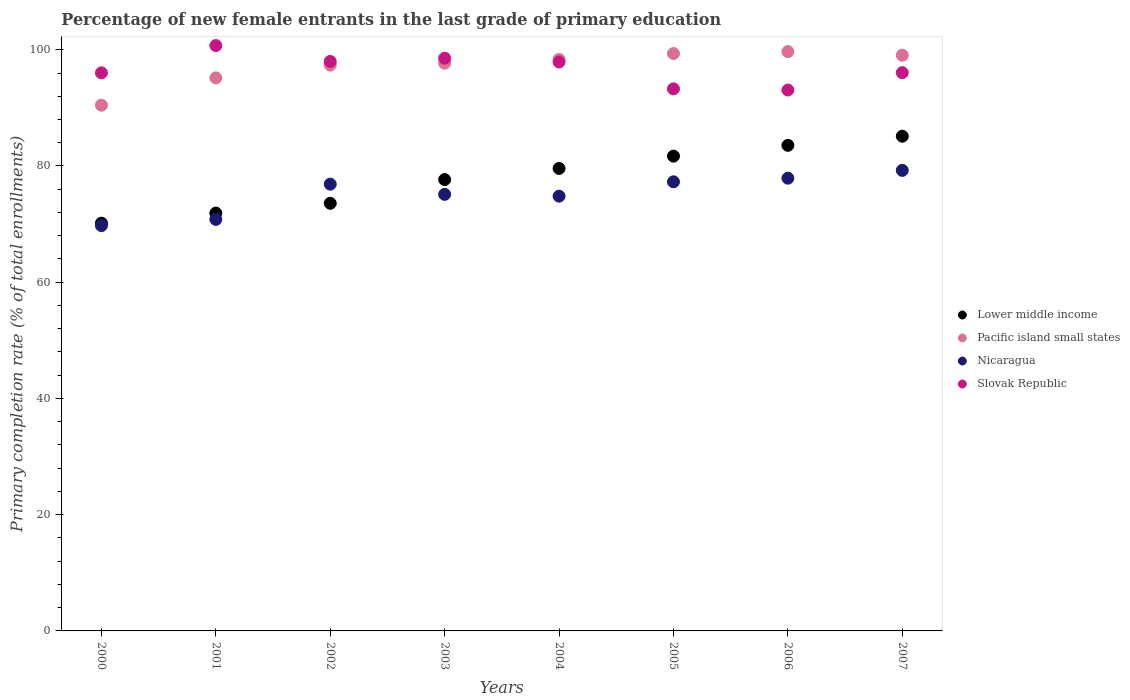What is the percentage of new female entrants in Nicaragua in 2004?
Your answer should be compact. 74.81. Across all years, what is the maximum percentage of new female entrants in Pacific island small states?
Make the answer very short. 99.68. Across all years, what is the minimum percentage of new female entrants in Nicaragua?
Provide a succinct answer. 69.73. In which year was the percentage of new female entrants in Nicaragua minimum?
Make the answer very short. 2000. What is the total percentage of new female entrants in Pacific island small states in the graph?
Your response must be concise. 777.11. What is the difference between the percentage of new female entrants in Lower middle income in 2002 and that in 2006?
Your answer should be very brief. -9.97. What is the difference between the percentage of new female entrants in Lower middle income in 2003 and the percentage of new female entrants in Pacific island small states in 2001?
Keep it short and to the point. -17.49. What is the average percentage of new female entrants in Lower middle income per year?
Your answer should be very brief. 77.91. In the year 2000, what is the difference between the percentage of new female entrants in Pacific island small states and percentage of new female entrants in Slovak Republic?
Offer a terse response. -5.57. In how many years, is the percentage of new female entrants in Lower middle income greater than 96 %?
Your answer should be compact. 0. What is the ratio of the percentage of new female entrants in Slovak Republic in 2002 to that in 2007?
Make the answer very short. 1.02. Is the percentage of new female entrants in Lower middle income in 2001 less than that in 2005?
Make the answer very short. Yes. Is the difference between the percentage of new female entrants in Pacific island small states in 2002 and 2005 greater than the difference between the percentage of new female entrants in Slovak Republic in 2002 and 2005?
Provide a short and direct response. No. What is the difference between the highest and the second highest percentage of new female entrants in Nicaragua?
Make the answer very short. 1.34. What is the difference between the highest and the lowest percentage of new female entrants in Lower middle income?
Your response must be concise. 14.96. Is the sum of the percentage of new female entrants in Lower middle income in 2004 and 2007 greater than the maximum percentage of new female entrants in Slovak Republic across all years?
Give a very brief answer. Yes. Is it the case that in every year, the sum of the percentage of new female entrants in Slovak Republic and percentage of new female entrants in Nicaragua  is greater than the sum of percentage of new female entrants in Lower middle income and percentage of new female entrants in Pacific island small states?
Provide a short and direct response. No. Does the percentage of new female entrants in Slovak Republic monotonically increase over the years?
Your answer should be very brief. No. Is the percentage of new female entrants in Pacific island small states strictly greater than the percentage of new female entrants in Nicaragua over the years?
Your response must be concise. Yes. Is the percentage of new female entrants in Pacific island small states strictly less than the percentage of new female entrants in Nicaragua over the years?
Your answer should be very brief. No. How many dotlines are there?
Your answer should be very brief. 4. How many years are there in the graph?
Give a very brief answer. 8. What is the difference between two consecutive major ticks on the Y-axis?
Provide a short and direct response. 20. Does the graph contain any zero values?
Your answer should be compact. No. How many legend labels are there?
Your response must be concise. 4. How are the legend labels stacked?
Give a very brief answer. Vertical. What is the title of the graph?
Offer a very short reply. Percentage of new female entrants in the last grade of primary education. Does "Jamaica" appear as one of the legend labels in the graph?
Make the answer very short. No. What is the label or title of the X-axis?
Provide a succinct answer. Years. What is the label or title of the Y-axis?
Your answer should be compact. Primary completion rate (% of total enrollments). What is the Primary completion rate (% of total enrollments) of Lower middle income in 2000?
Ensure brevity in your answer.  70.16. What is the Primary completion rate (% of total enrollments) of Pacific island small states in 2000?
Make the answer very short. 90.46. What is the Primary completion rate (% of total enrollments) in Nicaragua in 2000?
Give a very brief answer. 69.73. What is the Primary completion rate (% of total enrollments) in Slovak Republic in 2000?
Keep it short and to the point. 96.03. What is the Primary completion rate (% of total enrollments) of Lower middle income in 2001?
Your answer should be very brief. 71.9. What is the Primary completion rate (% of total enrollments) of Pacific island small states in 2001?
Offer a very short reply. 95.16. What is the Primary completion rate (% of total enrollments) of Nicaragua in 2001?
Ensure brevity in your answer.  70.81. What is the Primary completion rate (% of total enrollments) in Slovak Republic in 2001?
Your response must be concise. 100.72. What is the Primary completion rate (% of total enrollments) of Lower middle income in 2002?
Provide a short and direct response. 73.58. What is the Primary completion rate (% of total enrollments) in Pacific island small states in 2002?
Your answer should be very brief. 97.36. What is the Primary completion rate (% of total enrollments) of Nicaragua in 2002?
Your answer should be very brief. 76.87. What is the Primary completion rate (% of total enrollments) of Slovak Republic in 2002?
Make the answer very short. 98. What is the Primary completion rate (% of total enrollments) in Lower middle income in 2003?
Provide a succinct answer. 77.67. What is the Primary completion rate (% of total enrollments) of Pacific island small states in 2003?
Ensure brevity in your answer.  97.69. What is the Primary completion rate (% of total enrollments) of Nicaragua in 2003?
Your response must be concise. 75.12. What is the Primary completion rate (% of total enrollments) of Slovak Republic in 2003?
Offer a terse response. 98.55. What is the Primary completion rate (% of total enrollments) of Lower middle income in 2004?
Make the answer very short. 79.58. What is the Primary completion rate (% of total enrollments) in Pacific island small states in 2004?
Give a very brief answer. 98.34. What is the Primary completion rate (% of total enrollments) of Nicaragua in 2004?
Ensure brevity in your answer.  74.81. What is the Primary completion rate (% of total enrollments) in Slovak Republic in 2004?
Offer a very short reply. 97.89. What is the Primary completion rate (% of total enrollments) of Lower middle income in 2005?
Provide a short and direct response. 81.69. What is the Primary completion rate (% of total enrollments) of Pacific island small states in 2005?
Provide a succinct answer. 99.35. What is the Primary completion rate (% of total enrollments) of Nicaragua in 2005?
Your answer should be compact. 77.28. What is the Primary completion rate (% of total enrollments) in Slovak Republic in 2005?
Your answer should be very brief. 93.27. What is the Primary completion rate (% of total enrollments) of Lower middle income in 2006?
Your answer should be compact. 83.55. What is the Primary completion rate (% of total enrollments) in Pacific island small states in 2006?
Offer a very short reply. 99.68. What is the Primary completion rate (% of total enrollments) in Nicaragua in 2006?
Make the answer very short. 77.9. What is the Primary completion rate (% of total enrollments) of Slovak Republic in 2006?
Provide a short and direct response. 93.07. What is the Primary completion rate (% of total enrollments) in Lower middle income in 2007?
Offer a terse response. 85.12. What is the Primary completion rate (% of total enrollments) in Pacific island small states in 2007?
Give a very brief answer. 99.06. What is the Primary completion rate (% of total enrollments) in Nicaragua in 2007?
Your response must be concise. 79.25. What is the Primary completion rate (% of total enrollments) of Slovak Republic in 2007?
Offer a terse response. 96.06. Across all years, what is the maximum Primary completion rate (% of total enrollments) of Lower middle income?
Keep it short and to the point. 85.12. Across all years, what is the maximum Primary completion rate (% of total enrollments) of Pacific island small states?
Give a very brief answer. 99.68. Across all years, what is the maximum Primary completion rate (% of total enrollments) of Nicaragua?
Ensure brevity in your answer.  79.25. Across all years, what is the maximum Primary completion rate (% of total enrollments) of Slovak Republic?
Offer a very short reply. 100.72. Across all years, what is the minimum Primary completion rate (% of total enrollments) in Lower middle income?
Give a very brief answer. 70.16. Across all years, what is the minimum Primary completion rate (% of total enrollments) in Pacific island small states?
Keep it short and to the point. 90.46. Across all years, what is the minimum Primary completion rate (% of total enrollments) in Nicaragua?
Offer a very short reply. 69.73. Across all years, what is the minimum Primary completion rate (% of total enrollments) in Slovak Republic?
Keep it short and to the point. 93.07. What is the total Primary completion rate (% of total enrollments) in Lower middle income in the graph?
Your answer should be compact. 623.26. What is the total Primary completion rate (% of total enrollments) of Pacific island small states in the graph?
Keep it short and to the point. 777.11. What is the total Primary completion rate (% of total enrollments) in Nicaragua in the graph?
Keep it short and to the point. 601.77. What is the total Primary completion rate (% of total enrollments) of Slovak Republic in the graph?
Ensure brevity in your answer.  773.6. What is the difference between the Primary completion rate (% of total enrollments) of Lower middle income in 2000 and that in 2001?
Your response must be concise. -1.74. What is the difference between the Primary completion rate (% of total enrollments) of Pacific island small states in 2000 and that in 2001?
Ensure brevity in your answer.  -4.7. What is the difference between the Primary completion rate (% of total enrollments) of Nicaragua in 2000 and that in 2001?
Provide a short and direct response. -1.07. What is the difference between the Primary completion rate (% of total enrollments) in Slovak Republic in 2000 and that in 2001?
Your answer should be very brief. -4.69. What is the difference between the Primary completion rate (% of total enrollments) in Lower middle income in 2000 and that in 2002?
Your answer should be very brief. -3.42. What is the difference between the Primary completion rate (% of total enrollments) of Pacific island small states in 2000 and that in 2002?
Ensure brevity in your answer.  -6.9. What is the difference between the Primary completion rate (% of total enrollments) in Nicaragua in 2000 and that in 2002?
Your answer should be compact. -7.14. What is the difference between the Primary completion rate (% of total enrollments) of Slovak Republic in 2000 and that in 2002?
Your response must be concise. -1.97. What is the difference between the Primary completion rate (% of total enrollments) of Lower middle income in 2000 and that in 2003?
Provide a short and direct response. -7.51. What is the difference between the Primary completion rate (% of total enrollments) in Pacific island small states in 2000 and that in 2003?
Your answer should be very brief. -7.23. What is the difference between the Primary completion rate (% of total enrollments) of Nicaragua in 2000 and that in 2003?
Provide a short and direct response. -5.38. What is the difference between the Primary completion rate (% of total enrollments) in Slovak Republic in 2000 and that in 2003?
Keep it short and to the point. -2.52. What is the difference between the Primary completion rate (% of total enrollments) in Lower middle income in 2000 and that in 2004?
Your answer should be compact. -9.42. What is the difference between the Primary completion rate (% of total enrollments) of Pacific island small states in 2000 and that in 2004?
Offer a very short reply. -7.88. What is the difference between the Primary completion rate (% of total enrollments) of Nicaragua in 2000 and that in 2004?
Make the answer very short. -5.07. What is the difference between the Primary completion rate (% of total enrollments) of Slovak Republic in 2000 and that in 2004?
Ensure brevity in your answer.  -1.86. What is the difference between the Primary completion rate (% of total enrollments) of Lower middle income in 2000 and that in 2005?
Provide a short and direct response. -11.53. What is the difference between the Primary completion rate (% of total enrollments) of Pacific island small states in 2000 and that in 2005?
Provide a short and direct response. -8.89. What is the difference between the Primary completion rate (% of total enrollments) of Nicaragua in 2000 and that in 2005?
Keep it short and to the point. -7.54. What is the difference between the Primary completion rate (% of total enrollments) in Slovak Republic in 2000 and that in 2005?
Ensure brevity in your answer.  2.75. What is the difference between the Primary completion rate (% of total enrollments) of Lower middle income in 2000 and that in 2006?
Provide a short and direct response. -13.39. What is the difference between the Primary completion rate (% of total enrollments) of Pacific island small states in 2000 and that in 2006?
Provide a short and direct response. -9.22. What is the difference between the Primary completion rate (% of total enrollments) of Nicaragua in 2000 and that in 2006?
Give a very brief answer. -8.17. What is the difference between the Primary completion rate (% of total enrollments) of Slovak Republic in 2000 and that in 2006?
Ensure brevity in your answer.  2.96. What is the difference between the Primary completion rate (% of total enrollments) in Lower middle income in 2000 and that in 2007?
Ensure brevity in your answer.  -14.96. What is the difference between the Primary completion rate (% of total enrollments) of Pacific island small states in 2000 and that in 2007?
Provide a short and direct response. -8.6. What is the difference between the Primary completion rate (% of total enrollments) in Nicaragua in 2000 and that in 2007?
Offer a very short reply. -9.51. What is the difference between the Primary completion rate (% of total enrollments) of Slovak Republic in 2000 and that in 2007?
Provide a short and direct response. -0.03. What is the difference between the Primary completion rate (% of total enrollments) in Lower middle income in 2001 and that in 2002?
Give a very brief answer. -1.68. What is the difference between the Primary completion rate (% of total enrollments) of Pacific island small states in 2001 and that in 2002?
Your answer should be very brief. -2.2. What is the difference between the Primary completion rate (% of total enrollments) of Nicaragua in 2001 and that in 2002?
Offer a very short reply. -6.07. What is the difference between the Primary completion rate (% of total enrollments) of Slovak Republic in 2001 and that in 2002?
Your response must be concise. 2.72. What is the difference between the Primary completion rate (% of total enrollments) of Lower middle income in 2001 and that in 2003?
Your response must be concise. -5.77. What is the difference between the Primary completion rate (% of total enrollments) of Pacific island small states in 2001 and that in 2003?
Offer a terse response. -2.53. What is the difference between the Primary completion rate (% of total enrollments) in Nicaragua in 2001 and that in 2003?
Keep it short and to the point. -4.31. What is the difference between the Primary completion rate (% of total enrollments) of Slovak Republic in 2001 and that in 2003?
Provide a short and direct response. 2.17. What is the difference between the Primary completion rate (% of total enrollments) in Lower middle income in 2001 and that in 2004?
Give a very brief answer. -7.68. What is the difference between the Primary completion rate (% of total enrollments) in Pacific island small states in 2001 and that in 2004?
Make the answer very short. -3.18. What is the difference between the Primary completion rate (% of total enrollments) in Nicaragua in 2001 and that in 2004?
Make the answer very short. -4. What is the difference between the Primary completion rate (% of total enrollments) in Slovak Republic in 2001 and that in 2004?
Offer a terse response. 2.83. What is the difference between the Primary completion rate (% of total enrollments) of Lower middle income in 2001 and that in 2005?
Your answer should be compact. -9.79. What is the difference between the Primary completion rate (% of total enrollments) of Pacific island small states in 2001 and that in 2005?
Provide a short and direct response. -4.19. What is the difference between the Primary completion rate (% of total enrollments) in Nicaragua in 2001 and that in 2005?
Ensure brevity in your answer.  -6.47. What is the difference between the Primary completion rate (% of total enrollments) in Slovak Republic in 2001 and that in 2005?
Keep it short and to the point. 7.45. What is the difference between the Primary completion rate (% of total enrollments) in Lower middle income in 2001 and that in 2006?
Keep it short and to the point. -11.65. What is the difference between the Primary completion rate (% of total enrollments) of Pacific island small states in 2001 and that in 2006?
Give a very brief answer. -4.52. What is the difference between the Primary completion rate (% of total enrollments) in Nicaragua in 2001 and that in 2006?
Provide a short and direct response. -7.09. What is the difference between the Primary completion rate (% of total enrollments) in Slovak Republic in 2001 and that in 2006?
Your answer should be compact. 7.65. What is the difference between the Primary completion rate (% of total enrollments) in Lower middle income in 2001 and that in 2007?
Offer a very short reply. -13.22. What is the difference between the Primary completion rate (% of total enrollments) in Pacific island small states in 2001 and that in 2007?
Your answer should be very brief. -3.9. What is the difference between the Primary completion rate (% of total enrollments) of Nicaragua in 2001 and that in 2007?
Provide a short and direct response. -8.44. What is the difference between the Primary completion rate (% of total enrollments) in Slovak Republic in 2001 and that in 2007?
Ensure brevity in your answer.  4.66. What is the difference between the Primary completion rate (% of total enrollments) of Lower middle income in 2002 and that in 2003?
Provide a short and direct response. -4.08. What is the difference between the Primary completion rate (% of total enrollments) of Pacific island small states in 2002 and that in 2003?
Your answer should be very brief. -0.33. What is the difference between the Primary completion rate (% of total enrollments) of Nicaragua in 2002 and that in 2003?
Provide a short and direct response. 1.76. What is the difference between the Primary completion rate (% of total enrollments) in Slovak Republic in 2002 and that in 2003?
Give a very brief answer. -0.55. What is the difference between the Primary completion rate (% of total enrollments) in Lower middle income in 2002 and that in 2004?
Offer a very short reply. -6. What is the difference between the Primary completion rate (% of total enrollments) of Pacific island small states in 2002 and that in 2004?
Keep it short and to the point. -0.98. What is the difference between the Primary completion rate (% of total enrollments) in Nicaragua in 2002 and that in 2004?
Provide a short and direct response. 2.06. What is the difference between the Primary completion rate (% of total enrollments) in Slovak Republic in 2002 and that in 2004?
Your answer should be very brief. 0.1. What is the difference between the Primary completion rate (% of total enrollments) of Lower middle income in 2002 and that in 2005?
Your response must be concise. -8.11. What is the difference between the Primary completion rate (% of total enrollments) in Pacific island small states in 2002 and that in 2005?
Provide a short and direct response. -1.99. What is the difference between the Primary completion rate (% of total enrollments) in Nicaragua in 2002 and that in 2005?
Offer a very short reply. -0.41. What is the difference between the Primary completion rate (% of total enrollments) in Slovak Republic in 2002 and that in 2005?
Provide a short and direct response. 4.72. What is the difference between the Primary completion rate (% of total enrollments) in Lower middle income in 2002 and that in 2006?
Your answer should be very brief. -9.97. What is the difference between the Primary completion rate (% of total enrollments) in Pacific island small states in 2002 and that in 2006?
Keep it short and to the point. -2.33. What is the difference between the Primary completion rate (% of total enrollments) of Nicaragua in 2002 and that in 2006?
Provide a succinct answer. -1.03. What is the difference between the Primary completion rate (% of total enrollments) in Slovak Republic in 2002 and that in 2006?
Provide a short and direct response. 4.92. What is the difference between the Primary completion rate (% of total enrollments) in Lower middle income in 2002 and that in 2007?
Your answer should be very brief. -11.54. What is the difference between the Primary completion rate (% of total enrollments) of Pacific island small states in 2002 and that in 2007?
Ensure brevity in your answer.  -1.71. What is the difference between the Primary completion rate (% of total enrollments) of Nicaragua in 2002 and that in 2007?
Your answer should be compact. -2.37. What is the difference between the Primary completion rate (% of total enrollments) of Slovak Republic in 2002 and that in 2007?
Offer a terse response. 1.94. What is the difference between the Primary completion rate (% of total enrollments) in Lower middle income in 2003 and that in 2004?
Your response must be concise. -1.92. What is the difference between the Primary completion rate (% of total enrollments) of Pacific island small states in 2003 and that in 2004?
Provide a succinct answer. -0.65. What is the difference between the Primary completion rate (% of total enrollments) of Nicaragua in 2003 and that in 2004?
Your answer should be very brief. 0.31. What is the difference between the Primary completion rate (% of total enrollments) of Slovak Republic in 2003 and that in 2004?
Provide a short and direct response. 0.65. What is the difference between the Primary completion rate (% of total enrollments) of Lower middle income in 2003 and that in 2005?
Offer a terse response. -4.03. What is the difference between the Primary completion rate (% of total enrollments) of Pacific island small states in 2003 and that in 2005?
Keep it short and to the point. -1.66. What is the difference between the Primary completion rate (% of total enrollments) of Nicaragua in 2003 and that in 2005?
Your answer should be very brief. -2.16. What is the difference between the Primary completion rate (% of total enrollments) in Slovak Republic in 2003 and that in 2005?
Give a very brief answer. 5.27. What is the difference between the Primary completion rate (% of total enrollments) in Lower middle income in 2003 and that in 2006?
Give a very brief answer. -5.89. What is the difference between the Primary completion rate (% of total enrollments) of Pacific island small states in 2003 and that in 2006?
Provide a short and direct response. -1.99. What is the difference between the Primary completion rate (% of total enrollments) in Nicaragua in 2003 and that in 2006?
Keep it short and to the point. -2.78. What is the difference between the Primary completion rate (% of total enrollments) in Slovak Republic in 2003 and that in 2006?
Keep it short and to the point. 5.48. What is the difference between the Primary completion rate (% of total enrollments) in Lower middle income in 2003 and that in 2007?
Make the answer very short. -7.46. What is the difference between the Primary completion rate (% of total enrollments) in Pacific island small states in 2003 and that in 2007?
Give a very brief answer. -1.37. What is the difference between the Primary completion rate (% of total enrollments) in Nicaragua in 2003 and that in 2007?
Your answer should be compact. -4.13. What is the difference between the Primary completion rate (% of total enrollments) in Slovak Republic in 2003 and that in 2007?
Make the answer very short. 2.49. What is the difference between the Primary completion rate (% of total enrollments) of Lower middle income in 2004 and that in 2005?
Your response must be concise. -2.11. What is the difference between the Primary completion rate (% of total enrollments) in Pacific island small states in 2004 and that in 2005?
Give a very brief answer. -1.01. What is the difference between the Primary completion rate (% of total enrollments) in Nicaragua in 2004 and that in 2005?
Offer a terse response. -2.47. What is the difference between the Primary completion rate (% of total enrollments) of Slovak Republic in 2004 and that in 2005?
Ensure brevity in your answer.  4.62. What is the difference between the Primary completion rate (% of total enrollments) in Lower middle income in 2004 and that in 2006?
Make the answer very short. -3.97. What is the difference between the Primary completion rate (% of total enrollments) of Pacific island small states in 2004 and that in 2006?
Give a very brief answer. -1.34. What is the difference between the Primary completion rate (% of total enrollments) of Nicaragua in 2004 and that in 2006?
Provide a short and direct response. -3.09. What is the difference between the Primary completion rate (% of total enrollments) of Slovak Republic in 2004 and that in 2006?
Make the answer very short. 4.82. What is the difference between the Primary completion rate (% of total enrollments) in Lower middle income in 2004 and that in 2007?
Provide a short and direct response. -5.54. What is the difference between the Primary completion rate (% of total enrollments) in Pacific island small states in 2004 and that in 2007?
Offer a terse response. -0.72. What is the difference between the Primary completion rate (% of total enrollments) in Nicaragua in 2004 and that in 2007?
Offer a terse response. -4.44. What is the difference between the Primary completion rate (% of total enrollments) in Slovak Republic in 2004 and that in 2007?
Your answer should be very brief. 1.84. What is the difference between the Primary completion rate (% of total enrollments) in Lower middle income in 2005 and that in 2006?
Offer a terse response. -1.86. What is the difference between the Primary completion rate (% of total enrollments) of Pacific island small states in 2005 and that in 2006?
Provide a succinct answer. -0.33. What is the difference between the Primary completion rate (% of total enrollments) of Nicaragua in 2005 and that in 2006?
Provide a short and direct response. -0.62. What is the difference between the Primary completion rate (% of total enrollments) in Slovak Republic in 2005 and that in 2006?
Give a very brief answer. 0.2. What is the difference between the Primary completion rate (% of total enrollments) of Lower middle income in 2005 and that in 2007?
Provide a succinct answer. -3.43. What is the difference between the Primary completion rate (% of total enrollments) in Pacific island small states in 2005 and that in 2007?
Provide a short and direct response. 0.29. What is the difference between the Primary completion rate (% of total enrollments) of Nicaragua in 2005 and that in 2007?
Make the answer very short. -1.97. What is the difference between the Primary completion rate (% of total enrollments) in Slovak Republic in 2005 and that in 2007?
Give a very brief answer. -2.78. What is the difference between the Primary completion rate (% of total enrollments) in Lower middle income in 2006 and that in 2007?
Your answer should be compact. -1.57. What is the difference between the Primary completion rate (% of total enrollments) of Pacific island small states in 2006 and that in 2007?
Provide a short and direct response. 0.62. What is the difference between the Primary completion rate (% of total enrollments) in Nicaragua in 2006 and that in 2007?
Make the answer very short. -1.34. What is the difference between the Primary completion rate (% of total enrollments) of Slovak Republic in 2006 and that in 2007?
Provide a short and direct response. -2.99. What is the difference between the Primary completion rate (% of total enrollments) in Lower middle income in 2000 and the Primary completion rate (% of total enrollments) in Pacific island small states in 2001?
Provide a short and direct response. -25. What is the difference between the Primary completion rate (% of total enrollments) of Lower middle income in 2000 and the Primary completion rate (% of total enrollments) of Nicaragua in 2001?
Your response must be concise. -0.65. What is the difference between the Primary completion rate (% of total enrollments) of Lower middle income in 2000 and the Primary completion rate (% of total enrollments) of Slovak Republic in 2001?
Make the answer very short. -30.56. What is the difference between the Primary completion rate (% of total enrollments) of Pacific island small states in 2000 and the Primary completion rate (% of total enrollments) of Nicaragua in 2001?
Offer a very short reply. 19.65. What is the difference between the Primary completion rate (% of total enrollments) in Pacific island small states in 2000 and the Primary completion rate (% of total enrollments) in Slovak Republic in 2001?
Your response must be concise. -10.26. What is the difference between the Primary completion rate (% of total enrollments) of Nicaragua in 2000 and the Primary completion rate (% of total enrollments) of Slovak Republic in 2001?
Ensure brevity in your answer.  -30.99. What is the difference between the Primary completion rate (% of total enrollments) of Lower middle income in 2000 and the Primary completion rate (% of total enrollments) of Pacific island small states in 2002?
Offer a terse response. -27.2. What is the difference between the Primary completion rate (% of total enrollments) in Lower middle income in 2000 and the Primary completion rate (% of total enrollments) in Nicaragua in 2002?
Your response must be concise. -6.71. What is the difference between the Primary completion rate (% of total enrollments) of Lower middle income in 2000 and the Primary completion rate (% of total enrollments) of Slovak Republic in 2002?
Provide a short and direct response. -27.84. What is the difference between the Primary completion rate (% of total enrollments) in Pacific island small states in 2000 and the Primary completion rate (% of total enrollments) in Nicaragua in 2002?
Ensure brevity in your answer.  13.59. What is the difference between the Primary completion rate (% of total enrollments) of Pacific island small states in 2000 and the Primary completion rate (% of total enrollments) of Slovak Republic in 2002?
Provide a short and direct response. -7.54. What is the difference between the Primary completion rate (% of total enrollments) in Nicaragua in 2000 and the Primary completion rate (% of total enrollments) in Slovak Republic in 2002?
Give a very brief answer. -28.26. What is the difference between the Primary completion rate (% of total enrollments) in Lower middle income in 2000 and the Primary completion rate (% of total enrollments) in Pacific island small states in 2003?
Your answer should be compact. -27.53. What is the difference between the Primary completion rate (% of total enrollments) of Lower middle income in 2000 and the Primary completion rate (% of total enrollments) of Nicaragua in 2003?
Your answer should be compact. -4.96. What is the difference between the Primary completion rate (% of total enrollments) in Lower middle income in 2000 and the Primary completion rate (% of total enrollments) in Slovak Republic in 2003?
Your answer should be very brief. -28.39. What is the difference between the Primary completion rate (% of total enrollments) in Pacific island small states in 2000 and the Primary completion rate (% of total enrollments) in Nicaragua in 2003?
Give a very brief answer. 15.34. What is the difference between the Primary completion rate (% of total enrollments) of Pacific island small states in 2000 and the Primary completion rate (% of total enrollments) of Slovak Republic in 2003?
Give a very brief answer. -8.09. What is the difference between the Primary completion rate (% of total enrollments) in Nicaragua in 2000 and the Primary completion rate (% of total enrollments) in Slovak Republic in 2003?
Provide a short and direct response. -28.81. What is the difference between the Primary completion rate (% of total enrollments) of Lower middle income in 2000 and the Primary completion rate (% of total enrollments) of Pacific island small states in 2004?
Provide a succinct answer. -28.18. What is the difference between the Primary completion rate (% of total enrollments) of Lower middle income in 2000 and the Primary completion rate (% of total enrollments) of Nicaragua in 2004?
Your answer should be compact. -4.65. What is the difference between the Primary completion rate (% of total enrollments) of Lower middle income in 2000 and the Primary completion rate (% of total enrollments) of Slovak Republic in 2004?
Your answer should be very brief. -27.73. What is the difference between the Primary completion rate (% of total enrollments) of Pacific island small states in 2000 and the Primary completion rate (% of total enrollments) of Nicaragua in 2004?
Keep it short and to the point. 15.65. What is the difference between the Primary completion rate (% of total enrollments) in Pacific island small states in 2000 and the Primary completion rate (% of total enrollments) in Slovak Republic in 2004?
Your answer should be compact. -7.43. What is the difference between the Primary completion rate (% of total enrollments) in Nicaragua in 2000 and the Primary completion rate (% of total enrollments) in Slovak Republic in 2004?
Ensure brevity in your answer.  -28.16. What is the difference between the Primary completion rate (% of total enrollments) of Lower middle income in 2000 and the Primary completion rate (% of total enrollments) of Pacific island small states in 2005?
Give a very brief answer. -29.19. What is the difference between the Primary completion rate (% of total enrollments) of Lower middle income in 2000 and the Primary completion rate (% of total enrollments) of Nicaragua in 2005?
Your answer should be very brief. -7.12. What is the difference between the Primary completion rate (% of total enrollments) in Lower middle income in 2000 and the Primary completion rate (% of total enrollments) in Slovak Republic in 2005?
Your answer should be compact. -23.11. What is the difference between the Primary completion rate (% of total enrollments) of Pacific island small states in 2000 and the Primary completion rate (% of total enrollments) of Nicaragua in 2005?
Your answer should be compact. 13.18. What is the difference between the Primary completion rate (% of total enrollments) of Pacific island small states in 2000 and the Primary completion rate (% of total enrollments) of Slovak Republic in 2005?
Ensure brevity in your answer.  -2.81. What is the difference between the Primary completion rate (% of total enrollments) in Nicaragua in 2000 and the Primary completion rate (% of total enrollments) in Slovak Republic in 2005?
Your answer should be compact. -23.54. What is the difference between the Primary completion rate (% of total enrollments) in Lower middle income in 2000 and the Primary completion rate (% of total enrollments) in Pacific island small states in 2006?
Your answer should be very brief. -29.52. What is the difference between the Primary completion rate (% of total enrollments) of Lower middle income in 2000 and the Primary completion rate (% of total enrollments) of Nicaragua in 2006?
Provide a succinct answer. -7.74. What is the difference between the Primary completion rate (% of total enrollments) in Lower middle income in 2000 and the Primary completion rate (% of total enrollments) in Slovak Republic in 2006?
Your response must be concise. -22.91. What is the difference between the Primary completion rate (% of total enrollments) in Pacific island small states in 2000 and the Primary completion rate (% of total enrollments) in Nicaragua in 2006?
Give a very brief answer. 12.56. What is the difference between the Primary completion rate (% of total enrollments) in Pacific island small states in 2000 and the Primary completion rate (% of total enrollments) in Slovak Republic in 2006?
Provide a succinct answer. -2.61. What is the difference between the Primary completion rate (% of total enrollments) in Nicaragua in 2000 and the Primary completion rate (% of total enrollments) in Slovak Republic in 2006?
Make the answer very short. -23.34. What is the difference between the Primary completion rate (% of total enrollments) in Lower middle income in 2000 and the Primary completion rate (% of total enrollments) in Pacific island small states in 2007?
Offer a terse response. -28.9. What is the difference between the Primary completion rate (% of total enrollments) of Lower middle income in 2000 and the Primary completion rate (% of total enrollments) of Nicaragua in 2007?
Keep it short and to the point. -9.09. What is the difference between the Primary completion rate (% of total enrollments) of Lower middle income in 2000 and the Primary completion rate (% of total enrollments) of Slovak Republic in 2007?
Provide a short and direct response. -25.9. What is the difference between the Primary completion rate (% of total enrollments) of Pacific island small states in 2000 and the Primary completion rate (% of total enrollments) of Nicaragua in 2007?
Provide a short and direct response. 11.21. What is the difference between the Primary completion rate (% of total enrollments) in Pacific island small states in 2000 and the Primary completion rate (% of total enrollments) in Slovak Republic in 2007?
Ensure brevity in your answer.  -5.6. What is the difference between the Primary completion rate (% of total enrollments) in Nicaragua in 2000 and the Primary completion rate (% of total enrollments) in Slovak Republic in 2007?
Offer a very short reply. -26.32. What is the difference between the Primary completion rate (% of total enrollments) of Lower middle income in 2001 and the Primary completion rate (% of total enrollments) of Pacific island small states in 2002?
Give a very brief answer. -25.46. What is the difference between the Primary completion rate (% of total enrollments) of Lower middle income in 2001 and the Primary completion rate (% of total enrollments) of Nicaragua in 2002?
Offer a terse response. -4.97. What is the difference between the Primary completion rate (% of total enrollments) of Lower middle income in 2001 and the Primary completion rate (% of total enrollments) of Slovak Republic in 2002?
Make the answer very short. -26.1. What is the difference between the Primary completion rate (% of total enrollments) of Pacific island small states in 2001 and the Primary completion rate (% of total enrollments) of Nicaragua in 2002?
Give a very brief answer. 18.29. What is the difference between the Primary completion rate (% of total enrollments) in Pacific island small states in 2001 and the Primary completion rate (% of total enrollments) in Slovak Republic in 2002?
Offer a terse response. -2.84. What is the difference between the Primary completion rate (% of total enrollments) in Nicaragua in 2001 and the Primary completion rate (% of total enrollments) in Slovak Republic in 2002?
Your answer should be compact. -27.19. What is the difference between the Primary completion rate (% of total enrollments) of Lower middle income in 2001 and the Primary completion rate (% of total enrollments) of Pacific island small states in 2003?
Your answer should be compact. -25.79. What is the difference between the Primary completion rate (% of total enrollments) of Lower middle income in 2001 and the Primary completion rate (% of total enrollments) of Nicaragua in 2003?
Offer a terse response. -3.22. What is the difference between the Primary completion rate (% of total enrollments) in Lower middle income in 2001 and the Primary completion rate (% of total enrollments) in Slovak Republic in 2003?
Your answer should be compact. -26.65. What is the difference between the Primary completion rate (% of total enrollments) of Pacific island small states in 2001 and the Primary completion rate (% of total enrollments) of Nicaragua in 2003?
Your response must be concise. 20.04. What is the difference between the Primary completion rate (% of total enrollments) of Pacific island small states in 2001 and the Primary completion rate (% of total enrollments) of Slovak Republic in 2003?
Your answer should be very brief. -3.39. What is the difference between the Primary completion rate (% of total enrollments) in Nicaragua in 2001 and the Primary completion rate (% of total enrollments) in Slovak Republic in 2003?
Give a very brief answer. -27.74. What is the difference between the Primary completion rate (% of total enrollments) in Lower middle income in 2001 and the Primary completion rate (% of total enrollments) in Pacific island small states in 2004?
Provide a short and direct response. -26.44. What is the difference between the Primary completion rate (% of total enrollments) of Lower middle income in 2001 and the Primary completion rate (% of total enrollments) of Nicaragua in 2004?
Give a very brief answer. -2.91. What is the difference between the Primary completion rate (% of total enrollments) in Lower middle income in 2001 and the Primary completion rate (% of total enrollments) in Slovak Republic in 2004?
Your answer should be compact. -25.99. What is the difference between the Primary completion rate (% of total enrollments) in Pacific island small states in 2001 and the Primary completion rate (% of total enrollments) in Nicaragua in 2004?
Provide a succinct answer. 20.35. What is the difference between the Primary completion rate (% of total enrollments) in Pacific island small states in 2001 and the Primary completion rate (% of total enrollments) in Slovak Republic in 2004?
Your answer should be compact. -2.73. What is the difference between the Primary completion rate (% of total enrollments) in Nicaragua in 2001 and the Primary completion rate (% of total enrollments) in Slovak Republic in 2004?
Offer a terse response. -27.09. What is the difference between the Primary completion rate (% of total enrollments) in Lower middle income in 2001 and the Primary completion rate (% of total enrollments) in Pacific island small states in 2005?
Give a very brief answer. -27.45. What is the difference between the Primary completion rate (% of total enrollments) in Lower middle income in 2001 and the Primary completion rate (% of total enrollments) in Nicaragua in 2005?
Your answer should be compact. -5.38. What is the difference between the Primary completion rate (% of total enrollments) of Lower middle income in 2001 and the Primary completion rate (% of total enrollments) of Slovak Republic in 2005?
Give a very brief answer. -21.38. What is the difference between the Primary completion rate (% of total enrollments) of Pacific island small states in 2001 and the Primary completion rate (% of total enrollments) of Nicaragua in 2005?
Ensure brevity in your answer.  17.88. What is the difference between the Primary completion rate (% of total enrollments) in Pacific island small states in 2001 and the Primary completion rate (% of total enrollments) in Slovak Republic in 2005?
Ensure brevity in your answer.  1.89. What is the difference between the Primary completion rate (% of total enrollments) in Nicaragua in 2001 and the Primary completion rate (% of total enrollments) in Slovak Republic in 2005?
Offer a very short reply. -22.47. What is the difference between the Primary completion rate (% of total enrollments) in Lower middle income in 2001 and the Primary completion rate (% of total enrollments) in Pacific island small states in 2006?
Your answer should be very brief. -27.78. What is the difference between the Primary completion rate (% of total enrollments) of Lower middle income in 2001 and the Primary completion rate (% of total enrollments) of Nicaragua in 2006?
Make the answer very short. -6. What is the difference between the Primary completion rate (% of total enrollments) of Lower middle income in 2001 and the Primary completion rate (% of total enrollments) of Slovak Republic in 2006?
Provide a succinct answer. -21.17. What is the difference between the Primary completion rate (% of total enrollments) of Pacific island small states in 2001 and the Primary completion rate (% of total enrollments) of Nicaragua in 2006?
Your response must be concise. 17.26. What is the difference between the Primary completion rate (% of total enrollments) in Pacific island small states in 2001 and the Primary completion rate (% of total enrollments) in Slovak Republic in 2006?
Your answer should be very brief. 2.09. What is the difference between the Primary completion rate (% of total enrollments) of Nicaragua in 2001 and the Primary completion rate (% of total enrollments) of Slovak Republic in 2006?
Offer a very short reply. -22.26. What is the difference between the Primary completion rate (% of total enrollments) in Lower middle income in 2001 and the Primary completion rate (% of total enrollments) in Pacific island small states in 2007?
Provide a succinct answer. -27.16. What is the difference between the Primary completion rate (% of total enrollments) in Lower middle income in 2001 and the Primary completion rate (% of total enrollments) in Nicaragua in 2007?
Give a very brief answer. -7.35. What is the difference between the Primary completion rate (% of total enrollments) of Lower middle income in 2001 and the Primary completion rate (% of total enrollments) of Slovak Republic in 2007?
Give a very brief answer. -24.16. What is the difference between the Primary completion rate (% of total enrollments) in Pacific island small states in 2001 and the Primary completion rate (% of total enrollments) in Nicaragua in 2007?
Your answer should be very brief. 15.91. What is the difference between the Primary completion rate (% of total enrollments) in Pacific island small states in 2001 and the Primary completion rate (% of total enrollments) in Slovak Republic in 2007?
Provide a short and direct response. -0.9. What is the difference between the Primary completion rate (% of total enrollments) of Nicaragua in 2001 and the Primary completion rate (% of total enrollments) of Slovak Republic in 2007?
Ensure brevity in your answer.  -25.25. What is the difference between the Primary completion rate (% of total enrollments) in Lower middle income in 2002 and the Primary completion rate (% of total enrollments) in Pacific island small states in 2003?
Offer a very short reply. -24.11. What is the difference between the Primary completion rate (% of total enrollments) in Lower middle income in 2002 and the Primary completion rate (% of total enrollments) in Nicaragua in 2003?
Your response must be concise. -1.54. What is the difference between the Primary completion rate (% of total enrollments) in Lower middle income in 2002 and the Primary completion rate (% of total enrollments) in Slovak Republic in 2003?
Keep it short and to the point. -24.97. What is the difference between the Primary completion rate (% of total enrollments) of Pacific island small states in 2002 and the Primary completion rate (% of total enrollments) of Nicaragua in 2003?
Give a very brief answer. 22.24. What is the difference between the Primary completion rate (% of total enrollments) in Pacific island small states in 2002 and the Primary completion rate (% of total enrollments) in Slovak Republic in 2003?
Ensure brevity in your answer.  -1.19. What is the difference between the Primary completion rate (% of total enrollments) of Nicaragua in 2002 and the Primary completion rate (% of total enrollments) of Slovak Republic in 2003?
Keep it short and to the point. -21.68. What is the difference between the Primary completion rate (% of total enrollments) in Lower middle income in 2002 and the Primary completion rate (% of total enrollments) in Pacific island small states in 2004?
Provide a succinct answer. -24.76. What is the difference between the Primary completion rate (% of total enrollments) in Lower middle income in 2002 and the Primary completion rate (% of total enrollments) in Nicaragua in 2004?
Provide a succinct answer. -1.23. What is the difference between the Primary completion rate (% of total enrollments) in Lower middle income in 2002 and the Primary completion rate (% of total enrollments) in Slovak Republic in 2004?
Keep it short and to the point. -24.31. What is the difference between the Primary completion rate (% of total enrollments) of Pacific island small states in 2002 and the Primary completion rate (% of total enrollments) of Nicaragua in 2004?
Offer a very short reply. 22.55. What is the difference between the Primary completion rate (% of total enrollments) in Pacific island small states in 2002 and the Primary completion rate (% of total enrollments) in Slovak Republic in 2004?
Make the answer very short. -0.54. What is the difference between the Primary completion rate (% of total enrollments) of Nicaragua in 2002 and the Primary completion rate (% of total enrollments) of Slovak Republic in 2004?
Offer a terse response. -21.02. What is the difference between the Primary completion rate (% of total enrollments) in Lower middle income in 2002 and the Primary completion rate (% of total enrollments) in Pacific island small states in 2005?
Provide a succinct answer. -25.77. What is the difference between the Primary completion rate (% of total enrollments) of Lower middle income in 2002 and the Primary completion rate (% of total enrollments) of Nicaragua in 2005?
Offer a terse response. -3.7. What is the difference between the Primary completion rate (% of total enrollments) in Lower middle income in 2002 and the Primary completion rate (% of total enrollments) in Slovak Republic in 2005?
Provide a succinct answer. -19.69. What is the difference between the Primary completion rate (% of total enrollments) in Pacific island small states in 2002 and the Primary completion rate (% of total enrollments) in Nicaragua in 2005?
Offer a very short reply. 20.08. What is the difference between the Primary completion rate (% of total enrollments) of Pacific island small states in 2002 and the Primary completion rate (% of total enrollments) of Slovak Republic in 2005?
Keep it short and to the point. 4.08. What is the difference between the Primary completion rate (% of total enrollments) in Nicaragua in 2002 and the Primary completion rate (% of total enrollments) in Slovak Republic in 2005?
Offer a terse response. -16.4. What is the difference between the Primary completion rate (% of total enrollments) in Lower middle income in 2002 and the Primary completion rate (% of total enrollments) in Pacific island small states in 2006?
Provide a short and direct response. -26.1. What is the difference between the Primary completion rate (% of total enrollments) of Lower middle income in 2002 and the Primary completion rate (% of total enrollments) of Nicaragua in 2006?
Keep it short and to the point. -4.32. What is the difference between the Primary completion rate (% of total enrollments) in Lower middle income in 2002 and the Primary completion rate (% of total enrollments) in Slovak Republic in 2006?
Keep it short and to the point. -19.49. What is the difference between the Primary completion rate (% of total enrollments) of Pacific island small states in 2002 and the Primary completion rate (% of total enrollments) of Nicaragua in 2006?
Your answer should be very brief. 19.46. What is the difference between the Primary completion rate (% of total enrollments) of Pacific island small states in 2002 and the Primary completion rate (% of total enrollments) of Slovak Republic in 2006?
Keep it short and to the point. 4.28. What is the difference between the Primary completion rate (% of total enrollments) in Nicaragua in 2002 and the Primary completion rate (% of total enrollments) in Slovak Republic in 2006?
Offer a terse response. -16.2. What is the difference between the Primary completion rate (% of total enrollments) in Lower middle income in 2002 and the Primary completion rate (% of total enrollments) in Pacific island small states in 2007?
Ensure brevity in your answer.  -25.48. What is the difference between the Primary completion rate (% of total enrollments) of Lower middle income in 2002 and the Primary completion rate (% of total enrollments) of Nicaragua in 2007?
Your answer should be compact. -5.66. What is the difference between the Primary completion rate (% of total enrollments) in Lower middle income in 2002 and the Primary completion rate (% of total enrollments) in Slovak Republic in 2007?
Provide a succinct answer. -22.48. What is the difference between the Primary completion rate (% of total enrollments) of Pacific island small states in 2002 and the Primary completion rate (% of total enrollments) of Nicaragua in 2007?
Offer a very short reply. 18.11. What is the difference between the Primary completion rate (% of total enrollments) of Pacific island small states in 2002 and the Primary completion rate (% of total enrollments) of Slovak Republic in 2007?
Provide a succinct answer. 1.3. What is the difference between the Primary completion rate (% of total enrollments) of Nicaragua in 2002 and the Primary completion rate (% of total enrollments) of Slovak Republic in 2007?
Your answer should be very brief. -19.19. What is the difference between the Primary completion rate (% of total enrollments) of Lower middle income in 2003 and the Primary completion rate (% of total enrollments) of Pacific island small states in 2004?
Your answer should be very brief. -20.67. What is the difference between the Primary completion rate (% of total enrollments) of Lower middle income in 2003 and the Primary completion rate (% of total enrollments) of Nicaragua in 2004?
Make the answer very short. 2.86. What is the difference between the Primary completion rate (% of total enrollments) of Lower middle income in 2003 and the Primary completion rate (% of total enrollments) of Slovak Republic in 2004?
Keep it short and to the point. -20.23. What is the difference between the Primary completion rate (% of total enrollments) in Pacific island small states in 2003 and the Primary completion rate (% of total enrollments) in Nicaragua in 2004?
Your answer should be very brief. 22.88. What is the difference between the Primary completion rate (% of total enrollments) in Pacific island small states in 2003 and the Primary completion rate (% of total enrollments) in Slovak Republic in 2004?
Keep it short and to the point. -0.2. What is the difference between the Primary completion rate (% of total enrollments) of Nicaragua in 2003 and the Primary completion rate (% of total enrollments) of Slovak Republic in 2004?
Make the answer very short. -22.78. What is the difference between the Primary completion rate (% of total enrollments) of Lower middle income in 2003 and the Primary completion rate (% of total enrollments) of Pacific island small states in 2005?
Give a very brief answer. -21.69. What is the difference between the Primary completion rate (% of total enrollments) in Lower middle income in 2003 and the Primary completion rate (% of total enrollments) in Nicaragua in 2005?
Ensure brevity in your answer.  0.39. What is the difference between the Primary completion rate (% of total enrollments) of Lower middle income in 2003 and the Primary completion rate (% of total enrollments) of Slovak Republic in 2005?
Ensure brevity in your answer.  -15.61. What is the difference between the Primary completion rate (% of total enrollments) in Pacific island small states in 2003 and the Primary completion rate (% of total enrollments) in Nicaragua in 2005?
Your response must be concise. 20.41. What is the difference between the Primary completion rate (% of total enrollments) of Pacific island small states in 2003 and the Primary completion rate (% of total enrollments) of Slovak Republic in 2005?
Your answer should be compact. 4.42. What is the difference between the Primary completion rate (% of total enrollments) in Nicaragua in 2003 and the Primary completion rate (% of total enrollments) in Slovak Republic in 2005?
Keep it short and to the point. -18.16. What is the difference between the Primary completion rate (% of total enrollments) in Lower middle income in 2003 and the Primary completion rate (% of total enrollments) in Pacific island small states in 2006?
Provide a short and direct response. -22.02. What is the difference between the Primary completion rate (% of total enrollments) of Lower middle income in 2003 and the Primary completion rate (% of total enrollments) of Nicaragua in 2006?
Your response must be concise. -0.24. What is the difference between the Primary completion rate (% of total enrollments) of Lower middle income in 2003 and the Primary completion rate (% of total enrollments) of Slovak Republic in 2006?
Give a very brief answer. -15.41. What is the difference between the Primary completion rate (% of total enrollments) in Pacific island small states in 2003 and the Primary completion rate (% of total enrollments) in Nicaragua in 2006?
Ensure brevity in your answer.  19.79. What is the difference between the Primary completion rate (% of total enrollments) of Pacific island small states in 2003 and the Primary completion rate (% of total enrollments) of Slovak Republic in 2006?
Offer a very short reply. 4.62. What is the difference between the Primary completion rate (% of total enrollments) in Nicaragua in 2003 and the Primary completion rate (% of total enrollments) in Slovak Republic in 2006?
Your answer should be very brief. -17.95. What is the difference between the Primary completion rate (% of total enrollments) in Lower middle income in 2003 and the Primary completion rate (% of total enrollments) in Pacific island small states in 2007?
Your answer should be compact. -21.4. What is the difference between the Primary completion rate (% of total enrollments) in Lower middle income in 2003 and the Primary completion rate (% of total enrollments) in Nicaragua in 2007?
Your answer should be compact. -1.58. What is the difference between the Primary completion rate (% of total enrollments) of Lower middle income in 2003 and the Primary completion rate (% of total enrollments) of Slovak Republic in 2007?
Provide a short and direct response. -18.39. What is the difference between the Primary completion rate (% of total enrollments) of Pacific island small states in 2003 and the Primary completion rate (% of total enrollments) of Nicaragua in 2007?
Offer a terse response. 18.44. What is the difference between the Primary completion rate (% of total enrollments) of Pacific island small states in 2003 and the Primary completion rate (% of total enrollments) of Slovak Republic in 2007?
Ensure brevity in your answer.  1.63. What is the difference between the Primary completion rate (% of total enrollments) of Nicaragua in 2003 and the Primary completion rate (% of total enrollments) of Slovak Republic in 2007?
Your answer should be very brief. -20.94. What is the difference between the Primary completion rate (% of total enrollments) of Lower middle income in 2004 and the Primary completion rate (% of total enrollments) of Pacific island small states in 2005?
Your answer should be very brief. -19.77. What is the difference between the Primary completion rate (% of total enrollments) of Lower middle income in 2004 and the Primary completion rate (% of total enrollments) of Nicaragua in 2005?
Your answer should be compact. 2.3. What is the difference between the Primary completion rate (% of total enrollments) of Lower middle income in 2004 and the Primary completion rate (% of total enrollments) of Slovak Republic in 2005?
Provide a succinct answer. -13.69. What is the difference between the Primary completion rate (% of total enrollments) in Pacific island small states in 2004 and the Primary completion rate (% of total enrollments) in Nicaragua in 2005?
Ensure brevity in your answer.  21.06. What is the difference between the Primary completion rate (% of total enrollments) of Pacific island small states in 2004 and the Primary completion rate (% of total enrollments) of Slovak Republic in 2005?
Keep it short and to the point. 5.07. What is the difference between the Primary completion rate (% of total enrollments) in Nicaragua in 2004 and the Primary completion rate (% of total enrollments) in Slovak Republic in 2005?
Your answer should be very brief. -18.47. What is the difference between the Primary completion rate (% of total enrollments) in Lower middle income in 2004 and the Primary completion rate (% of total enrollments) in Pacific island small states in 2006?
Provide a succinct answer. -20.1. What is the difference between the Primary completion rate (% of total enrollments) of Lower middle income in 2004 and the Primary completion rate (% of total enrollments) of Nicaragua in 2006?
Provide a short and direct response. 1.68. What is the difference between the Primary completion rate (% of total enrollments) in Lower middle income in 2004 and the Primary completion rate (% of total enrollments) in Slovak Republic in 2006?
Your answer should be compact. -13.49. What is the difference between the Primary completion rate (% of total enrollments) of Pacific island small states in 2004 and the Primary completion rate (% of total enrollments) of Nicaragua in 2006?
Provide a succinct answer. 20.44. What is the difference between the Primary completion rate (% of total enrollments) in Pacific island small states in 2004 and the Primary completion rate (% of total enrollments) in Slovak Republic in 2006?
Offer a very short reply. 5.27. What is the difference between the Primary completion rate (% of total enrollments) in Nicaragua in 2004 and the Primary completion rate (% of total enrollments) in Slovak Republic in 2006?
Keep it short and to the point. -18.26. What is the difference between the Primary completion rate (% of total enrollments) of Lower middle income in 2004 and the Primary completion rate (% of total enrollments) of Pacific island small states in 2007?
Your answer should be compact. -19.48. What is the difference between the Primary completion rate (% of total enrollments) in Lower middle income in 2004 and the Primary completion rate (% of total enrollments) in Nicaragua in 2007?
Give a very brief answer. 0.33. What is the difference between the Primary completion rate (% of total enrollments) in Lower middle income in 2004 and the Primary completion rate (% of total enrollments) in Slovak Republic in 2007?
Your response must be concise. -16.48. What is the difference between the Primary completion rate (% of total enrollments) in Pacific island small states in 2004 and the Primary completion rate (% of total enrollments) in Nicaragua in 2007?
Your answer should be very brief. 19.09. What is the difference between the Primary completion rate (% of total enrollments) in Pacific island small states in 2004 and the Primary completion rate (% of total enrollments) in Slovak Republic in 2007?
Provide a short and direct response. 2.28. What is the difference between the Primary completion rate (% of total enrollments) in Nicaragua in 2004 and the Primary completion rate (% of total enrollments) in Slovak Republic in 2007?
Make the answer very short. -21.25. What is the difference between the Primary completion rate (% of total enrollments) in Lower middle income in 2005 and the Primary completion rate (% of total enrollments) in Pacific island small states in 2006?
Give a very brief answer. -17.99. What is the difference between the Primary completion rate (% of total enrollments) of Lower middle income in 2005 and the Primary completion rate (% of total enrollments) of Nicaragua in 2006?
Give a very brief answer. 3.79. What is the difference between the Primary completion rate (% of total enrollments) of Lower middle income in 2005 and the Primary completion rate (% of total enrollments) of Slovak Republic in 2006?
Provide a short and direct response. -11.38. What is the difference between the Primary completion rate (% of total enrollments) in Pacific island small states in 2005 and the Primary completion rate (% of total enrollments) in Nicaragua in 2006?
Your answer should be very brief. 21.45. What is the difference between the Primary completion rate (% of total enrollments) of Pacific island small states in 2005 and the Primary completion rate (% of total enrollments) of Slovak Republic in 2006?
Provide a short and direct response. 6.28. What is the difference between the Primary completion rate (% of total enrollments) of Nicaragua in 2005 and the Primary completion rate (% of total enrollments) of Slovak Republic in 2006?
Give a very brief answer. -15.79. What is the difference between the Primary completion rate (% of total enrollments) in Lower middle income in 2005 and the Primary completion rate (% of total enrollments) in Pacific island small states in 2007?
Your response must be concise. -17.37. What is the difference between the Primary completion rate (% of total enrollments) of Lower middle income in 2005 and the Primary completion rate (% of total enrollments) of Nicaragua in 2007?
Your answer should be compact. 2.45. What is the difference between the Primary completion rate (% of total enrollments) in Lower middle income in 2005 and the Primary completion rate (% of total enrollments) in Slovak Republic in 2007?
Make the answer very short. -14.37. What is the difference between the Primary completion rate (% of total enrollments) in Pacific island small states in 2005 and the Primary completion rate (% of total enrollments) in Nicaragua in 2007?
Offer a very short reply. 20.11. What is the difference between the Primary completion rate (% of total enrollments) in Pacific island small states in 2005 and the Primary completion rate (% of total enrollments) in Slovak Republic in 2007?
Provide a short and direct response. 3.29. What is the difference between the Primary completion rate (% of total enrollments) in Nicaragua in 2005 and the Primary completion rate (% of total enrollments) in Slovak Republic in 2007?
Your answer should be compact. -18.78. What is the difference between the Primary completion rate (% of total enrollments) in Lower middle income in 2006 and the Primary completion rate (% of total enrollments) in Pacific island small states in 2007?
Your answer should be compact. -15.51. What is the difference between the Primary completion rate (% of total enrollments) of Lower middle income in 2006 and the Primary completion rate (% of total enrollments) of Nicaragua in 2007?
Offer a very short reply. 4.31. What is the difference between the Primary completion rate (% of total enrollments) in Lower middle income in 2006 and the Primary completion rate (% of total enrollments) in Slovak Republic in 2007?
Your answer should be very brief. -12.5. What is the difference between the Primary completion rate (% of total enrollments) in Pacific island small states in 2006 and the Primary completion rate (% of total enrollments) in Nicaragua in 2007?
Your answer should be very brief. 20.44. What is the difference between the Primary completion rate (% of total enrollments) of Pacific island small states in 2006 and the Primary completion rate (% of total enrollments) of Slovak Republic in 2007?
Give a very brief answer. 3.62. What is the difference between the Primary completion rate (% of total enrollments) in Nicaragua in 2006 and the Primary completion rate (% of total enrollments) in Slovak Republic in 2007?
Give a very brief answer. -18.16. What is the average Primary completion rate (% of total enrollments) of Lower middle income per year?
Make the answer very short. 77.91. What is the average Primary completion rate (% of total enrollments) in Pacific island small states per year?
Give a very brief answer. 97.14. What is the average Primary completion rate (% of total enrollments) in Nicaragua per year?
Offer a very short reply. 75.22. What is the average Primary completion rate (% of total enrollments) in Slovak Republic per year?
Offer a terse response. 96.7. In the year 2000, what is the difference between the Primary completion rate (% of total enrollments) in Lower middle income and Primary completion rate (% of total enrollments) in Pacific island small states?
Make the answer very short. -20.3. In the year 2000, what is the difference between the Primary completion rate (% of total enrollments) in Lower middle income and Primary completion rate (% of total enrollments) in Nicaragua?
Offer a terse response. 0.43. In the year 2000, what is the difference between the Primary completion rate (% of total enrollments) in Lower middle income and Primary completion rate (% of total enrollments) in Slovak Republic?
Provide a succinct answer. -25.87. In the year 2000, what is the difference between the Primary completion rate (% of total enrollments) in Pacific island small states and Primary completion rate (% of total enrollments) in Nicaragua?
Your answer should be very brief. 20.73. In the year 2000, what is the difference between the Primary completion rate (% of total enrollments) in Pacific island small states and Primary completion rate (% of total enrollments) in Slovak Republic?
Make the answer very short. -5.57. In the year 2000, what is the difference between the Primary completion rate (% of total enrollments) of Nicaragua and Primary completion rate (% of total enrollments) of Slovak Republic?
Provide a succinct answer. -26.3. In the year 2001, what is the difference between the Primary completion rate (% of total enrollments) of Lower middle income and Primary completion rate (% of total enrollments) of Pacific island small states?
Ensure brevity in your answer.  -23.26. In the year 2001, what is the difference between the Primary completion rate (% of total enrollments) in Lower middle income and Primary completion rate (% of total enrollments) in Nicaragua?
Your answer should be compact. 1.09. In the year 2001, what is the difference between the Primary completion rate (% of total enrollments) of Lower middle income and Primary completion rate (% of total enrollments) of Slovak Republic?
Give a very brief answer. -28.82. In the year 2001, what is the difference between the Primary completion rate (% of total enrollments) of Pacific island small states and Primary completion rate (% of total enrollments) of Nicaragua?
Offer a terse response. 24.35. In the year 2001, what is the difference between the Primary completion rate (% of total enrollments) of Pacific island small states and Primary completion rate (% of total enrollments) of Slovak Republic?
Make the answer very short. -5.56. In the year 2001, what is the difference between the Primary completion rate (% of total enrollments) of Nicaragua and Primary completion rate (% of total enrollments) of Slovak Republic?
Your response must be concise. -29.91. In the year 2002, what is the difference between the Primary completion rate (% of total enrollments) of Lower middle income and Primary completion rate (% of total enrollments) of Pacific island small states?
Your answer should be compact. -23.78. In the year 2002, what is the difference between the Primary completion rate (% of total enrollments) in Lower middle income and Primary completion rate (% of total enrollments) in Nicaragua?
Your answer should be very brief. -3.29. In the year 2002, what is the difference between the Primary completion rate (% of total enrollments) in Lower middle income and Primary completion rate (% of total enrollments) in Slovak Republic?
Give a very brief answer. -24.42. In the year 2002, what is the difference between the Primary completion rate (% of total enrollments) of Pacific island small states and Primary completion rate (% of total enrollments) of Nicaragua?
Give a very brief answer. 20.48. In the year 2002, what is the difference between the Primary completion rate (% of total enrollments) of Pacific island small states and Primary completion rate (% of total enrollments) of Slovak Republic?
Keep it short and to the point. -0.64. In the year 2002, what is the difference between the Primary completion rate (% of total enrollments) of Nicaragua and Primary completion rate (% of total enrollments) of Slovak Republic?
Your response must be concise. -21.12. In the year 2003, what is the difference between the Primary completion rate (% of total enrollments) of Lower middle income and Primary completion rate (% of total enrollments) of Pacific island small states?
Give a very brief answer. -20.03. In the year 2003, what is the difference between the Primary completion rate (% of total enrollments) of Lower middle income and Primary completion rate (% of total enrollments) of Nicaragua?
Your answer should be compact. 2.55. In the year 2003, what is the difference between the Primary completion rate (% of total enrollments) in Lower middle income and Primary completion rate (% of total enrollments) in Slovak Republic?
Offer a very short reply. -20.88. In the year 2003, what is the difference between the Primary completion rate (% of total enrollments) of Pacific island small states and Primary completion rate (% of total enrollments) of Nicaragua?
Your answer should be compact. 22.57. In the year 2003, what is the difference between the Primary completion rate (% of total enrollments) of Pacific island small states and Primary completion rate (% of total enrollments) of Slovak Republic?
Make the answer very short. -0.86. In the year 2003, what is the difference between the Primary completion rate (% of total enrollments) of Nicaragua and Primary completion rate (% of total enrollments) of Slovak Republic?
Ensure brevity in your answer.  -23.43. In the year 2004, what is the difference between the Primary completion rate (% of total enrollments) of Lower middle income and Primary completion rate (% of total enrollments) of Pacific island small states?
Offer a terse response. -18.76. In the year 2004, what is the difference between the Primary completion rate (% of total enrollments) of Lower middle income and Primary completion rate (% of total enrollments) of Nicaragua?
Provide a succinct answer. 4.77. In the year 2004, what is the difference between the Primary completion rate (% of total enrollments) in Lower middle income and Primary completion rate (% of total enrollments) in Slovak Republic?
Your answer should be very brief. -18.31. In the year 2004, what is the difference between the Primary completion rate (% of total enrollments) in Pacific island small states and Primary completion rate (% of total enrollments) in Nicaragua?
Provide a short and direct response. 23.53. In the year 2004, what is the difference between the Primary completion rate (% of total enrollments) of Pacific island small states and Primary completion rate (% of total enrollments) of Slovak Republic?
Offer a terse response. 0.45. In the year 2004, what is the difference between the Primary completion rate (% of total enrollments) in Nicaragua and Primary completion rate (% of total enrollments) in Slovak Republic?
Provide a succinct answer. -23.09. In the year 2005, what is the difference between the Primary completion rate (% of total enrollments) of Lower middle income and Primary completion rate (% of total enrollments) of Pacific island small states?
Make the answer very short. -17.66. In the year 2005, what is the difference between the Primary completion rate (% of total enrollments) of Lower middle income and Primary completion rate (% of total enrollments) of Nicaragua?
Ensure brevity in your answer.  4.41. In the year 2005, what is the difference between the Primary completion rate (% of total enrollments) of Lower middle income and Primary completion rate (% of total enrollments) of Slovak Republic?
Keep it short and to the point. -11.58. In the year 2005, what is the difference between the Primary completion rate (% of total enrollments) of Pacific island small states and Primary completion rate (% of total enrollments) of Nicaragua?
Offer a very short reply. 22.07. In the year 2005, what is the difference between the Primary completion rate (% of total enrollments) in Pacific island small states and Primary completion rate (% of total enrollments) in Slovak Republic?
Provide a succinct answer. 6.08. In the year 2005, what is the difference between the Primary completion rate (% of total enrollments) in Nicaragua and Primary completion rate (% of total enrollments) in Slovak Republic?
Your answer should be compact. -16. In the year 2006, what is the difference between the Primary completion rate (% of total enrollments) in Lower middle income and Primary completion rate (% of total enrollments) in Pacific island small states?
Offer a terse response. -16.13. In the year 2006, what is the difference between the Primary completion rate (% of total enrollments) in Lower middle income and Primary completion rate (% of total enrollments) in Nicaragua?
Your response must be concise. 5.65. In the year 2006, what is the difference between the Primary completion rate (% of total enrollments) in Lower middle income and Primary completion rate (% of total enrollments) in Slovak Republic?
Your answer should be very brief. -9.52. In the year 2006, what is the difference between the Primary completion rate (% of total enrollments) of Pacific island small states and Primary completion rate (% of total enrollments) of Nicaragua?
Your answer should be compact. 21.78. In the year 2006, what is the difference between the Primary completion rate (% of total enrollments) of Pacific island small states and Primary completion rate (% of total enrollments) of Slovak Republic?
Give a very brief answer. 6.61. In the year 2006, what is the difference between the Primary completion rate (% of total enrollments) of Nicaragua and Primary completion rate (% of total enrollments) of Slovak Republic?
Your response must be concise. -15.17. In the year 2007, what is the difference between the Primary completion rate (% of total enrollments) in Lower middle income and Primary completion rate (% of total enrollments) in Pacific island small states?
Your answer should be very brief. -13.94. In the year 2007, what is the difference between the Primary completion rate (% of total enrollments) in Lower middle income and Primary completion rate (% of total enrollments) in Nicaragua?
Your answer should be very brief. 5.88. In the year 2007, what is the difference between the Primary completion rate (% of total enrollments) of Lower middle income and Primary completion rate (% of total enrollments) of Slovak Republic?
Your answer should be compact. -10.94. In the year 2007, what is the difference between the Primary completion rate (% of total enrollments) in Pacific island small states and Primary completion rate (% of total enrollments) in Nicaragua?
Provide a short and direct response. 19.82. In the year 2007, what is the difference between the Primary completion rate (% of total enrollments) of Pacific island small states and Primary completion rate (% of total enrollments) of Slovak Republic?
Ensure brevity in your answer.  3. In the year 2007, what is the difference between the Primary completion rate (% of total enrollments) in Nicaragua and Primary completion rate (% of total enrollments) in Slovak Republic?
Your answer should be compact. -16.81. What is the ratio of the Primary completion rate (% of total enrollments) of Lower middle income in 2000 to that in 2001?
Your answer should be very brief. 0.98. What is the ratio of the Primary completion rate (% of total enrollments) of Pacific island small states in 2000 to that in 2001?
Keep it short and to the point. 0.95. What is the ratio of the Primary completion rate (% of total enrollments) in Slovak Republic in 2000 to that in 2001?
Provide a short and direct response. 0.95. What is the ratio of the Primary completion rate (% of total enrollments) in Lower middle income in 2000 to that in 2002?
Provide a succinct answer. 0.95. What is the ratio of the Primary completion rate (% of total enrollments) in Pacific island small states in 2000 to that in 2002?
Give a very brief answer. 0.93. What is the ratio of the Primary completion rate (% of total enrollments) in Nicaragua in 2000 to that in 2002?
Offer a terse response. 0.91. What is the ratio of the Primary completion rate (% of total enrollments) in Slovak Republic in 2000 to that in 2002?
Your answer should be compact. 0.98. What is the ratio of the Primary completion rate (% of total enrollments) in Lower middle income in 2000 to that in 2003?
Keep it short and to the point. 0.9. What is the ratio of the Primary completion rate (% of total enrollments) in Pacific island small states in 2000 to that in 2003?
Offer a terse response. 0.93. What is the ratio of the Primary completion rate (% of total enrollments) in Nicaragua in 2000 to that in 2003?
Ensure brevity in your answer.  0.93. What is the ratio of the Primary completion rate (% of total enrollments) in Slovak Republic in 2000 to that in 2003?
Ensure brevity in your answer.  0.97. What is the ratio of the Primary completion rate (% of total enrollments) of Lower middle income in 2000 to that in 2004?
Your answer should be very brief. 0.88. What is the ratio of the Primary completion rate (% of total enrollments) of Pacific island small states in 2000 to that in 2004?
Offer a terse response. 0.92. What is the ratio of the Primary completion rate (% of total enrollments) in Nicaragua in 2000 to that in 2004?
Your answer should be very brief. 0.93. What is the ratio of the Primary completion rate (% of total enrollments) of Slovak Republic in 2000 to that in 2004?
Your response must be concise. 0.98. What is the ratio of the Primary completion rate (% of total enrollments) in Lower middle income in 2000 to that in 2005?
Your response must be concise. 0.86. What is the ratio of the Primary completion rate (% of total enrollments) of Pacific island small states in 2000 to that in 2005?
Your answer should be compact. 0.91. What is the ratio of the Primary completion rate (% of total enrollments) in Nicaragua in 2000 to that in 2005?
Make the answer very short. 0.9. What is the ratio of the Primary completion rate (% of total enrollments) of Slovak Republic in 2000 to that in 2005?
Keep it short and to the point. 1.03. What is the ratio of the Primary completion rate (% of total enrollments) of Lower middle income in 2000 to that in 2006?
Provide a succinct answer. 0.84. What is the ratio of the Primary completion rate (% of total enrollments) of Pacific island small states in 2000 to that in 2006?
Your response must be concise. 0.91. What is the ratio of the Primary completion rate (% of total enrollments) in Nicaragua in 2000 to that in 2006?
Make the answer very short. 0.9. What is the ratio of the Primary completion rate (% of total enrollments) in Slovak Republic in 2000 to that in 2006?
Keep it short and to the point. 1.03. What is the ratio of the Primary completion rate (% of total enrollments) in Lower middle income in 2000 to that in 2007?
Provide a succinct answer. 0.82. What is the ratio of the Primary completion rate (% of total enrollments) in Pacific island small states in 2000 to that in 2007?
Offer a terse response. 0.91. What is the ratio of the Primary completion rate (% of total enrollments) in Nicaragua in 2000 to that in 2007?
Provide a short and direct response. 0.88. What is the ratio of the Primary completion rate (% of total enrollments) in Lower middle income in 2001 to that in 2002?
Offer a terse response. 0.98. What is the ratio of the Primary completion rate (% of total enrollments) in Pacific island small states in 2001 to that in 2002?
Keep it short and to the point. 0.98. What is the ratio of the Primary completion rate (% of total enrollments) in Nicaragua in 2001 to that in 2002?
Provide a short and direct response. 0.92. What is the ratio of the Primary completion rate (% of total enrollments) of Slovak Republic in 2001 to that in 2002?
Keep it short and to the point. 1.03. What is the ratio of the Primary completion rate (% of total enrollments) in Lower middle income in 2001 to that in 2003?
Keep it short and to the point. 0.93. What is the ratio of the Primary completion rate (% of total enrollments) of Pacific island small states in 2001 to that in 2003?
Your answer should be very brief. 0.97. What is the ratio of the Primary completion rate (% of total enrollments) of Nicaragua in 2001 to that in 2003?
Keep it short and to the point. 0.94. What is the ratio of the Primary completion rate (% of total enrollments) of Slovak Republic in 2001 to that in 2003?
Your response must be concise. 1.02. What is the ratio of the Primary completion rate (% of total enrollments) of Lower middle income in 2001 to that in 2004?
Your response must be concise. 0.9. What is the ratio of the Primary completion rate (% of total enrollments) of Nicaragua in 2001 to that in 2004?
Your response must be concise. 0.95. What is the ratio of the Primary completion rate (% of total enrollments) in Slovak Republic in 2001 to that in 2004?
Provide a short and direct response. 1.03. What is the ratio of the Primary completion rate (% of total enrollments) in Lower middle income in 2001 to that in 2005?
Give a very brief answer. 0.88. What is the ratio of the Primary completion rate (% of total enrollments) of Pacific island small states in 2001 to that in 2005?
Your response must be concise. 0.96. What is the ratio of the Primary completion rate (% of total enrollments) of Nicaragua in 2001 to that in 2005?
Your answer should be compact. 0.92. What is the ratio of the Primary completion rate (% of total enrollments) of Slovak Republic in 2001 to that in 2005?
Keep it short and to the point. 1.08. What is the ratio of the Primary completion rate (% of total enrollments) of Lower middle income in 2001 to that in 2006?
Offer a terse response. 0.86. What is the ratio of the Primary completion rate (% of total enrollments) of Pacific island small states in 2001 to that in 2006?
Keep it short and to the point. 0.95. What is the ratio of the Primary completion rate (% of total enrollments) in Nicaragua in 2001 to that in 2006?
Offer a terse response. 0.91. What is the ratio of the Primary completion rate (% of total enrollments) of Slovak Republic in 2001 to that in 2006?
Your answer should be compact. 1.08. What is the ratio of the Primary completion rate (% of total enrollments) in Lower middle income in 2001 to that in 2007?
Keep it short and to the point. 0.84. What is the ratio of the Primary completion rate (% of total enrollments) in Pacific island small states in 2001 to that in 2007?
Provide a short and direct response. 0.96. What is the ratio of the Primary completion rate (% of total enrollments) of Nicaragua in 2001 to that in 2007?
Your response must be concise. 0.89. What is the ratio of the Primary completion rate (% of total enrollments) in Slovak Republic in 2001 to that in 2007?
Keep it short and to the point. 1.05. What is the ratio of the Primary completion rate (% of total enrollments) of Lower middle income in 2002 to that in 2003?
Your response must be concise. 0.95. What is the ratio of the Primary completion rate (% of total enrollments) of Nicaragua in 2002 to that in 2003?
Keep it short and to the point. 1.02. What is the ratio of the Primary completion rate (% of total enrollments) of Slovak Republic in 2002 to that in 2003?
Keep it short and to the point. 0.99. What is the ratio of the Primary completion rate (% of total enrollments) in Lower middle income in 2002 to that in 2004?
Ensure brevity in your answer.  0.92. What is the ratio of the Primary completion rate (% of total enrollments) in Nicaragua in 2002 to that in 2004?
Provide a succinct answer. 1.03. What is the ratio of the Primary completion rate (% of total enrollments) of Slovak Republic in 2002 to that in 2004?
Provide a succinct answer. 1. What is the ratio of the Primary completion rate (% of total enrollments) in Lower middle income in 2002 to that in 2005?
Your response must be concise. 0.9. What is the ratio of the Primary completion rate (% of total enrollments) in Pacific island small states in 2002 to that in 2005?
Make the answer very short. 0.98. What is the ratio of the Primary completion rate (% of total enrollments) of Slovak Republic in 2002 to that in 2005?
Ensure brevity in your answer.  1.05. What is the ratio of the Primary completion rate (% of total enrollments) in Lower middle income in 2002 to that in 2006?
Make the answer very short. 0.88. What is the ratio of the Primary completion rate (% of total enrollments) of Pacific island small states in 2002 to that in 2006?
Ensure brevity in your answer.  0.98. What is the ratio of the Primary completion rate (% of total enrollments) in Slovak Republic in 2002 to that in 2006?
Ensure brevity in your answer.  1.05. What is the ratio of the Primary completion rate (% of total enrollments) in Lower middle income in 2002 to that in 2007?
Provide a short and direct response. 0.86. What is the ratio of the Primary completion rate (% of total enrollments) in Pacific island small states in 2002 to that in 2007?
Your answer should be compact. 0.98. What is the ratio of the Primary completion rate (% of total enrollments) of Nicaragua in 2002 to that in 2007?
Your response must be concise. 0.97. What is the ratio of the Primary completion rate (% of total enrollments) of Slovak Republic in 2002 to that in 2007?
Your answer should be compact. 1.02. What is the ratio of the Primary completion rate (% of total enrollments) in Lower middle income in 2003 to that in 2004?
Keep it short and to the point. 0.98. What is the ratio of the Primary completion rate (% of total enrollments) in Nicaragua in 2003 to that in 2004?
Your answer should be very brief. 1. What is the ratio of the Primary completion rate (% of total enrollments) in Slovak Republic in 2003 to that in 2004?
Provide a short and direct response. 1.01. What is the ratio of the Primary completion rate (% of total enrollments) of Lower middle income in 2003 to that in 2005?
Offer a very short reply. 0.95. What is the ratio of the Primary completion rate (% of total enrollments) in Pacific island small states in 2003 to that in 2005?
Your answer should be compact. 0.98. What is the ratio of the Primary completion rate (% of total enrollments) of Slovak Republic in 2003 to that in 2005?
Ensure brevity in your answer.  1.06. What is the ratio of the Primary completion rate (% of total enrollments) of Lower middle income in 2003 to that in 2006?
Offer a terse response. 0.93. What is the ratio of the Primary completion rate (% of total enrollments) in Pacific island small states in 2003 to that in 2006?
Offer a very short reply. 0.98. What is the ratio of the Primary completion rate (% of total enrollments) in Nicaragua in 2003 to that in 2006?
Provide a succinct answer. 0.96. What is the ratio of the Primary completion rate (% of total enrollments) of Slovak Republic in 2003 to that in 2006?
Make the answer very short. 1.06. What is the ratio of the Primary completion rate (% of total enrollments) in Lower middle income in 2003 to that in 2007?
Your answer should be compact. 0.91. What is the ratio of the Primary completion rate (% of total enrollments) of Pacific island small states in 2003 to that in 2007?
Your answer should be very brief. 0.99. What is the ratio of the Primary completion rate (% of total enrollments) in Nicaragua in 2003 to that in 2007?
Your answer should be compact. 0.95. What is the ratio of the Primary completion rate (% of total enrollments) of Slovak Republic in 2003 to that in 2007?
Give a very brief answer. 1.03. What is the ratio of the Primary completion rate (% of total enrollments) of Lower middle income in 2004 to that in 2005?
Offer a very short reply. 0.97. What is the ratio of the Primary completion rate (% of total enrollments) in Pacific island small states in 2004 to that in 2005?
Make the answer very short. 0.99. What is the ratio of the Primary completion rate (% of total enrollments) of Nicaragua in 2004 to that in 2005?
Provide a succinct answer. 0.97. What is the ratio of the Primary completion rate (% of total enrollments) of Slovak Republic in 2004 to that in 2005?
Give a very brief answer. 1.05. What is the ratio of the Primary completion rate (% of total enrollments) of Lower middle income in 2004 to that in 2006?
Offer a very short reply. 0.95. What is the ratio of the Primary completion rate (% of total enrollments) in Pacific island small states in 2004 to that in 2006?
Give a very brief answer. 0.99. What is the ratio of the Primary completion rate (% of total enrollments) of Nicaragua in 2004 to that in 2006?
Keep it short and to the point. 0.96. What is the ratio of the Primary completion rate (% of total enrollments) in Slovak Republic in 2004 to that in 2006?
Make the answer very short. 1.05. What is the ratio of the Primary completion rate (% of total enrollments) of Lower middle income in 2004 to that in 2007?
Offer a terse response. 0.93. What is the ratio of the Primary completion rate (% of total enrollments) of Pacific island small states in 2004 to that in 2007?
Offer a terse response. 0.99. What is the ratio of the Primary completion rate (% of total enrollments) in Nicaragua in 2004 to that in 2007?
Give a very brief answer. 0.94. What is the ratio of the Primary completion rate (% of total enrollments) of Slovak Republic in 2004 to that in 2007?
Ensure brevity in your answer.  1.02. What is the ratio of the Primary completion rate (% of total enrollments) in Lower middle income in 2005 to that in 2006?
Offer a very short reply. 0.98. What is the ratio of the Primary completion rate (% of total enrollments) in Pacific island small states in 2005 to that in 2006?
Offer a very short reply. 1. What is the ratio of the Primary completion rate (% of total enrollments) of Nicaragua in 2005 to that in 2006?
Make the answer very short. 0.99. What is the ratio of the Primary completion rate (% of total enrollments) of Slovak Republic in 2005 to that in 2006?
Keep it short and to the point. 1. What is the ratio of the Primary completion rate (% of total enrollments) in Lower middle income in 2005 to that in 2007?
Your answer should be very brief. 0.96. What is the ratio of the Primary completion rate (% of total enrollments) of Pacific island small states in 2005 to that in 2007?
Keep it short and to the point. 1. What is the ratio of the Primary completion rate (% of total enrollments) in Nicaragua in 2005 to that in 2007?
Your response must be concise. 0.98. What is the ratio of the Primary completion rate (% of total enrollments) in Slovak Republic in 2005 to that in 2007?
Your answer should be very brief. 0.97. What is the ratio of the Primary completion rate (% of total enrollments) of Lower middle income in 2006 to that in 2007?
Offer a terse response. 0.98. What is the ratio of the Primary completion rate (% of total enrollments) of Nicaragua in 2006 to that in 2007?
Offer a very short reply. 0.98. What is the ratio of the Primary completion rate (% of total enrollments) in Slovak Republic in 2006 to that in 2007?
Offer a very short reply. 0.97. What is the difference between the highest and the second highest Primary completion rate (% of total enrollments) in Lower middle income?
Offer a terse response. 1.57. What is the difference between the highest and the second highest Primary completion rate (% of total enrollments) in Pacific island small states?
Provide a succinct answer. 0.33. What is the difference between the highest and the second highest Primary completion rate (% of total enrollments) in Nicaragua?
Provide a short and direct response. 1.34. What is the difference between the highest and the second highest Primary completion rate (% of total enrollments) of Slovak Republic?
Offer a terse response. 2.17. What is the difference between the highest and the lowest Primary completion rate (% of total enrollments) in Lower middle income?
Your response must be concise. 14.96. What is the difference between the highest and the lowest Primary completion rate (% of total enrollments) in Pacific island small states?
Provide a succinct answer. 9.22. What is the difference between the highest and the lowest Primary completion rate (% of total enrollments) in Nicaragua?
Your response must be concise. 9.51. What is the difference between the highest and the lowest Primary completion rate (% of total enrollments) in Slovak Republic?
Your response must be concise. 7.65. 